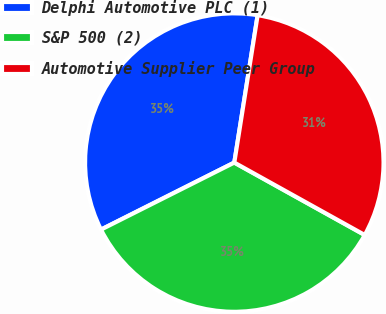Convert chart to OTSL. <chart><loc_0><loc_0><loc_500><loc_500><pie_chart><fcel>Delphi Automotive PLC (1)<fcel>S&P 500 (2)<fcel>Automotive Supplier Peer Group<nl><fcel>34.92%<fcel>34.52%<fcel>30.57%<nl></chart> 